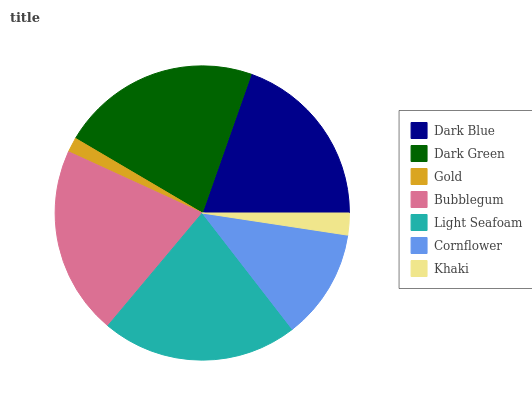Is Gold the minimum?
Answer yes or no. Yes. Is Dark Green the maximum?
Answer yes or no. Yes. Is Dark Green the minimum?
Answer yes or no. No. Is Gold the maximum?
Answer yes or no. No. Is Dark Green greater than Gold?
Answer yes or no. Yes. Is Gold less than Dark Green?
Answer yes or no. Yes. Is Gold greater than Dark Green?
Answer yes or no. No. Is Dark Green less than Gold?
Answer yes or no. No. Is Dark Blue the high median?
Answer yes or no. Yes. Is Dark Blue the low median?
Answer yes or no. Yes. Is Light Seafoam the high median?
Answer yes or no. No. Is Khaki the low median?
Answer yes or no. No. 